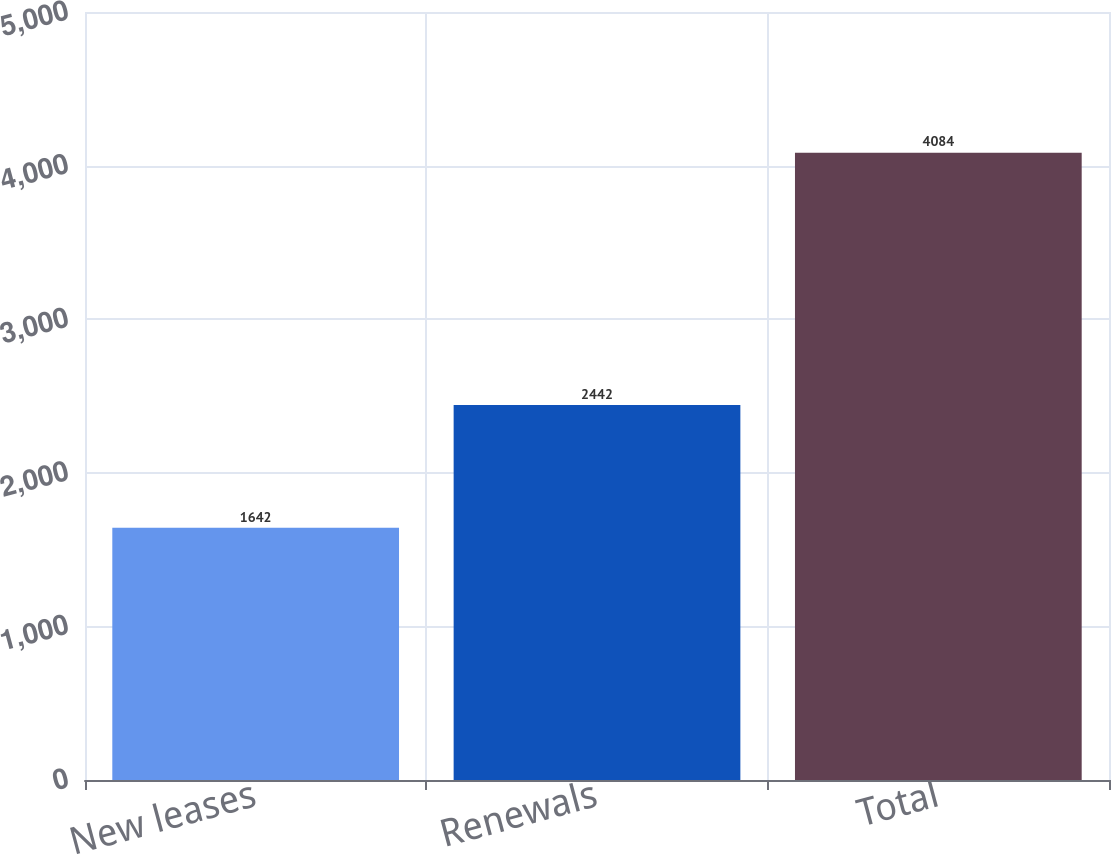Convert chart. <chart><loc_0><loc_0><loc_500><loc_500><bar_chart><fcel>New leases<fcel>Renewals<fcel>Total<nl><fcel>1642<fcel>2442<fcel>4084<nl></chart> 